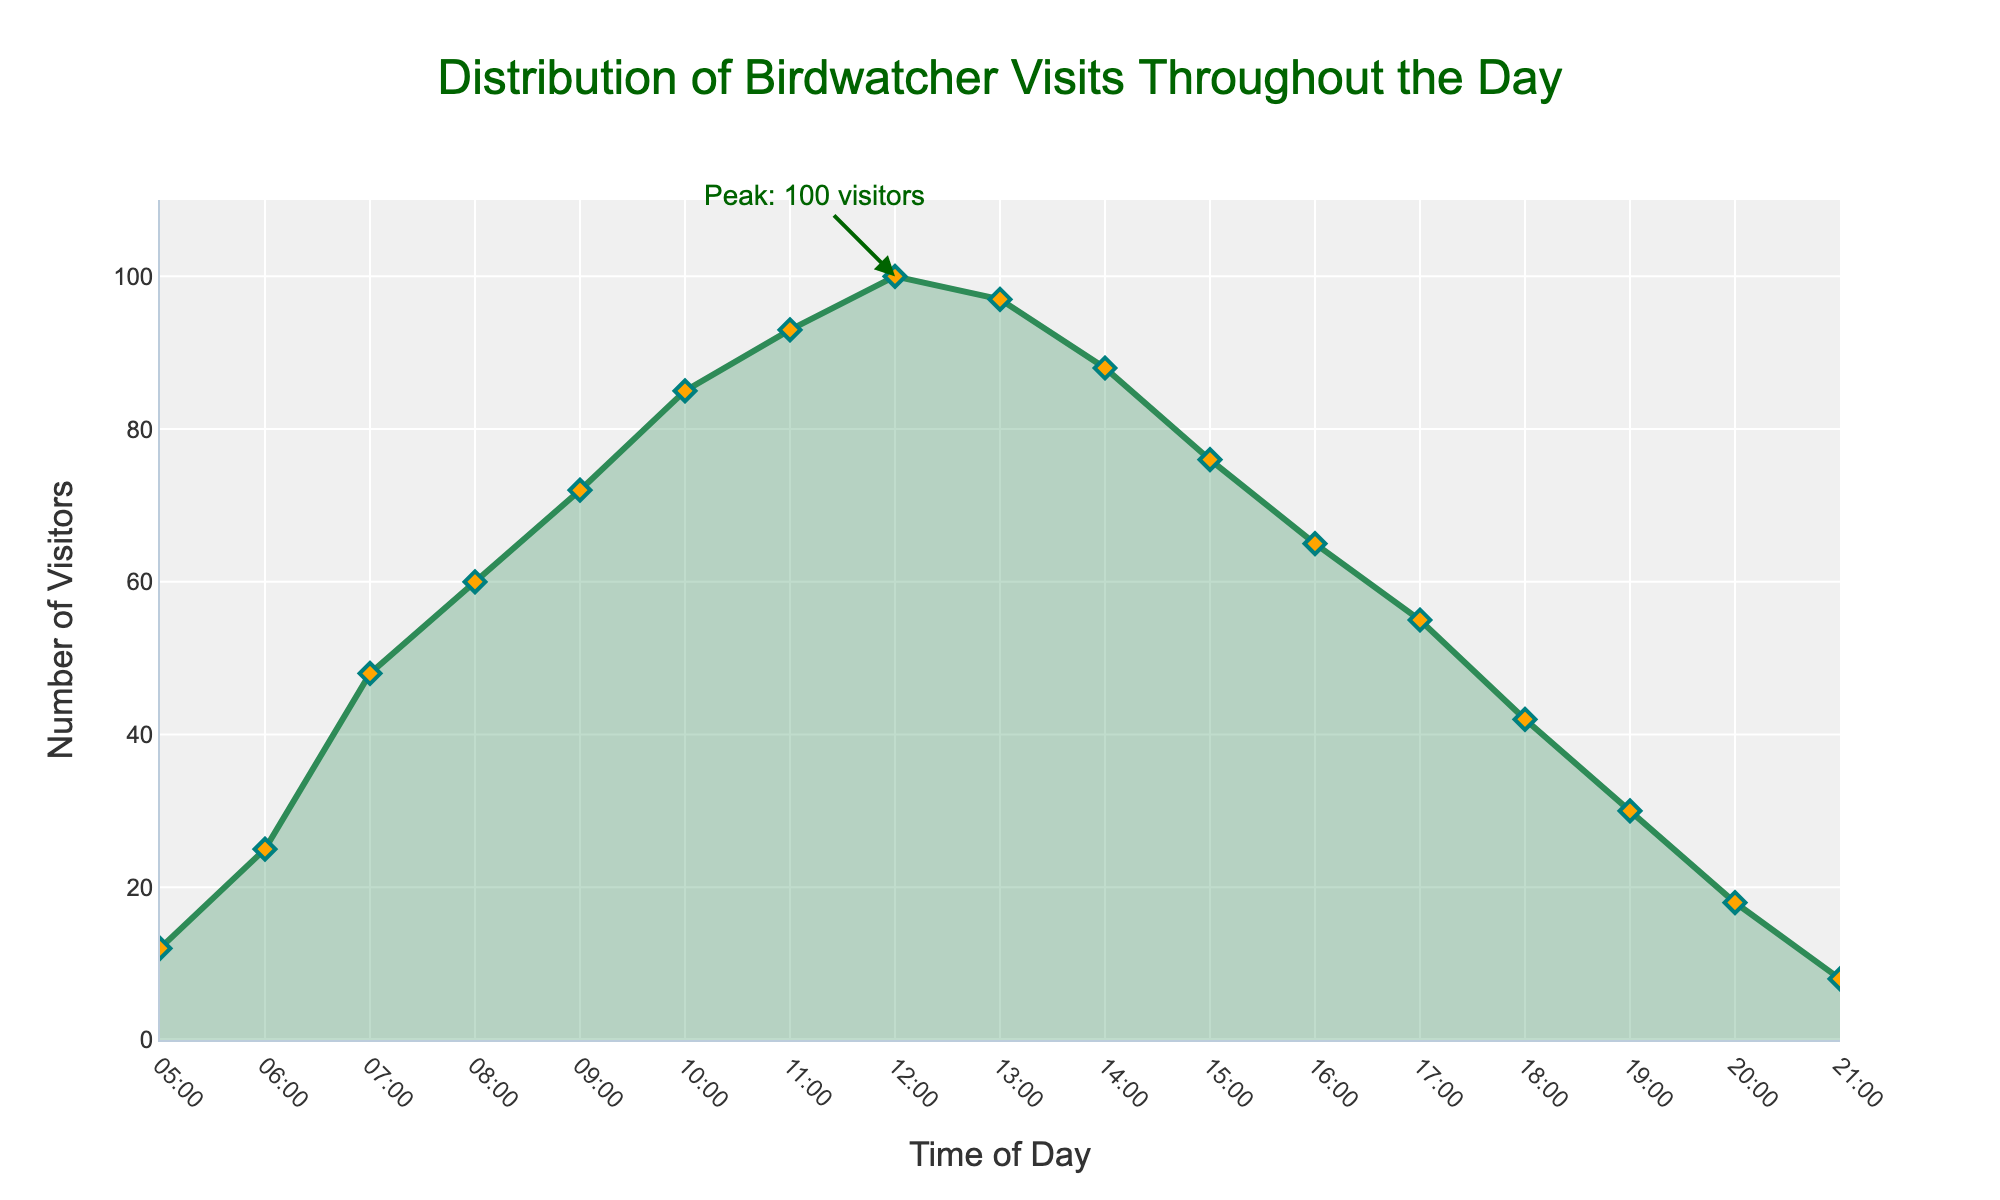What time of day has the highest number of visitors? The peak number of visitors is indicated at 12:00 with an annotation showing "Peak: 100 visitors".
Answer: 12:00 How does the number of visitors change from 09:00 to 13:00? The number of visitors increases from 72 at 09:00 to a peak of 100 at 12:00, then slightly decreases to 97 at 13:00.
Answer: Increases then decreases At which time is the number of visitors exactly 85? Referring to the y-axis value of 85, it aligns with 10:00 on the x-axis.
Answer: 10:00 What is the visitor count at 18:00, and how does it compare to the count at 17:00? The visitor count at 18:00 is 42, which is 13 less than the 55 visitors at 17:00.
Answer: 42; 13 less Give the total number of visitors from 05:00 to 21:00. Summing the visitor counts: 12 + 25 + 48 + 60 + 72 + 85 + 93 + 100 + 97 + 88 + 76 + 65 + 55 + 42 + 30 + 18 + 8 equals 974.
Answer: 974 What is the average number of visitors between 15:00 and 18:00 (inclusive)? The visitor counts at 15:00, 16:00, 17:00, and 18:00 are 76, 65, 55, and 42. The sum is 238, and the average is 238 / 4 = 59.5.
Answer: 59.5 Describe the trend in visitor numbers from 05:00 to 12:00. The number of visitors gradually increases from 12 at 05:00 to 100 at 12:00, showing a general upward trend throughout the morning.
Answer: Upward trend Which time interval sees the largest increase in visitors? The largest increase in visitors occurs between 06:00 and 07:00, where the count increases from 25 to 48, a difference of 23.
Answer: 06:00 to 07:00 Identify the times where the visitor count exceeds 90. The visitor count exceeds 90 at 11:00, 12:00, and 13:00.
Answer: 11:00, 12:00, 13:00 What is the range of visitor counts recorded? The lowest visitor count is 8 and the highest is 100. The range is 100 - 8 = 92.
Answer: 92 